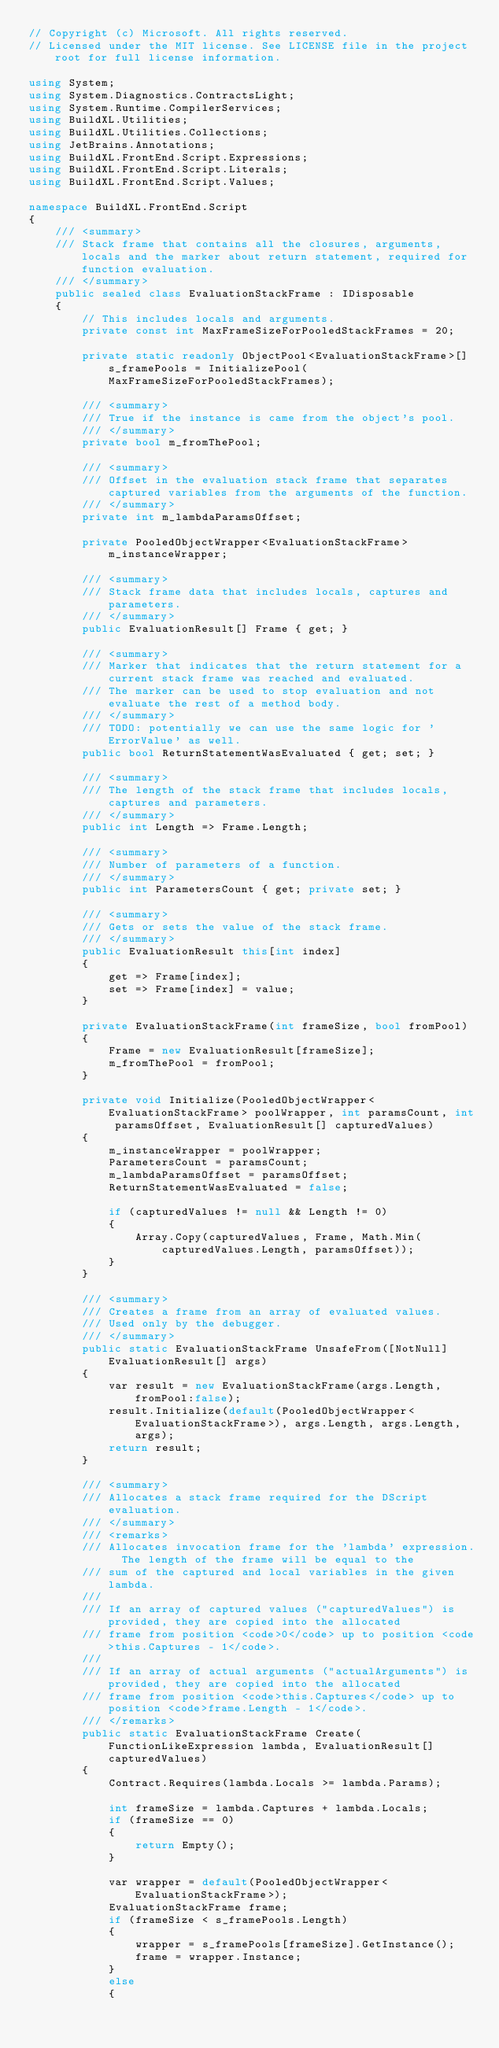Convert code to text. <code><loc_0><loc_0><loc_500><loc_500><_C#_>// Copyright (c) Microsoft. All rights reserved.
// Licensed under the MIT license. See LICENSE file in the project root for full license information.

using System;
using System.Diagnostics.ContractsLight;
using System.Runtime.CompilerServices;
using BuildXL.Utilities;
using BuildXL.Utilities.Collections;
using JetBrains.Annotations;
using BuildXL.FrontEnd.Script.Expressions;
using BuildXL.FrontEnd.Script.Literals;
using BuildXL.FrontEnd.Script.Values;

namespace BuildXL.FrontEnd.Script
{
    /// <summary>
    /// Stack frame that contains all the closures, arguments, locals and the marker about return statement, required for function evaluation.
    /// </summary>
    public sealed class EvaluationStackFrame : IDisposable
    {
        // This includes locals and arguments.
        private const int MaxFrameSizeForPooledStackFrames = 20;

        private static readonly ObjectPool<EvaluationStackFrame>[] s_framePools = InitializePool(MaxFrameSizeForPooledStackFrames);

        /// <summary>
        /// True if the instance is came from the object's pool.
        /// </summary>
        private bool m_fromThePool;
        
        /// <summary>
        /// Offset in the evaluation stack frame that separates captured variables from the arguments of the function.
        /// </summary>
        private int m_lambdaParamsOffset;

        private PooledObjectWrapper<EvaluationStackFrame> m_instanceWrapper;

        /// <summary>
        /// Stack frame data that includes locals, captures and parameters.
        /// </summary>
        public EvaluationResult[] Frame { get; }

        /// <summary>
        /// Marker that indicates that the return statement for a current stack frame was reached and evaluated.
        /// The marker can be used to stop evaluation and not evaluate the rest of a method body.
        /// </summary>
        /// TODO: potentially we can use the same logic for 'ErrorValue' as well.
        public bool ReturnStatementWasEvaluated { get; set; }

        /// <summary>
        /// The length of the stack frame that includes locals, captures and parameters.
        /// </summary>
        public int Length => Frame.Length;

        /// <summary>
        /// Number of parameters of a function.
        /// </summary>
        public int ParametersCount { get; private set; }

        /// <summary>
        /// Gets or sets the value of the stack frame.
        /// </summary>
        public EvaluationResult this[int index]
        {
            get => Frame[index];
            set => Frame[index] = value;
        }

        private EvaluationStackFrame(int frameSize, bool fromPool)
        {
            Frame = new EvaluationResult[frameSize];
            m_fromThePool = fromPool;
        }

        private void Initialize(PooledObjectWrapper<EvaluationStackFrame> poolWrapper, int paramsCount, int paramsOffset, EvaluationResult[] capturedValues)
        {
            m_instanceWrapper = poolWrapper;
            ParametersCount = paramsCount;
            m_lambdaParamsOffset = paramsOffset;
            ReturnStatementWasEvaluated = false;

            if (capturedValues != null && Length != 0)
            {
                Array.Copy(capturedValues, Frame, Math.Min(capturedValues.Length, paramsOffset));
            }
        }

        /// <summary>
        /// Creates a frame from an array of evaluated values.
        /// Used only by the debugger.
        /// </summary>
        public static EvaluationStackFrame UnsafeFrom([NotNull]EvaluationResult[] args)
        {
            var result = new EvaluationStackFrame(args.Length, fromPool:false);
            result.Initialize(default(PooledObjectWrapper<EvaluationStackFrame>), args.Length, args.Length, args);
            return result;
        }

        /// <summary>
        /// Allocates a stack frame required for the DScript evaluation.
        /// </summary>
        /// <remarks>
        /// Allocates invocation frame for the 'lambda' expression.  The length of the frame will be equal to the
        /// sum of the captured and local variables in the given lambda.
        ///
        /// If an array of captured values ("capturedValues") is provided, they are copied into the allocated
        /// frame from position <code>0</code> up to position <code>this.Captures - 1</code>.
        ///
        /// If an array of actual arguments ("actualArguments") is provided, they are copied into the allocated
        /// frame from position <code>this.Captures</code> up to position <code>frame.Length - 1</code>.
        /// </remarks>
        public static EvaluationStackFrame Create(FunctionLikeExpression lambda, EvaluationResult[] capturedValues)
        {
            Contract.Requires(lambda.Locals >= lambda.Params);

            int frameSize = lambda.Captures + lambda.Locals;
            if (frameSize == 0)
            {
                return Empty();
            }

            var wrapper = default(PooledObjectWrapper<EvaluationStackFrame>);
            EvaluationStackFrame frame;
            if (frameSize < s_framePools.Length)
            {
                wrapper = s_framePools[frameSize].GetInstance();
                frame = wrapper.Instance;
            }
            else
            {</code> 